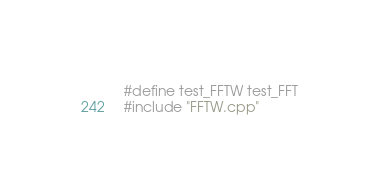<code> <loc_0><loc_0><loc_500><loc_500><_C++_>#define test_FFTW test_FFT
#include "FFTW.cpp"
</code> 